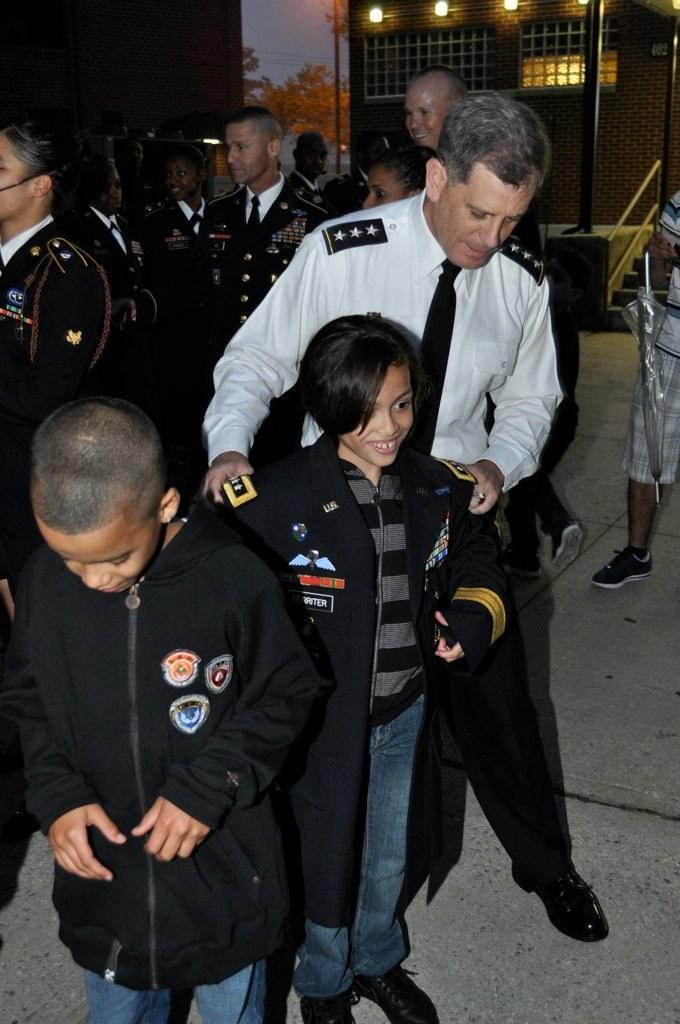Can you describe this image briefly? In this image, we can see person and kids wearing clothes. There are lights on building. There is a pole in the top right of the image. There are steps on the right side of the image. 